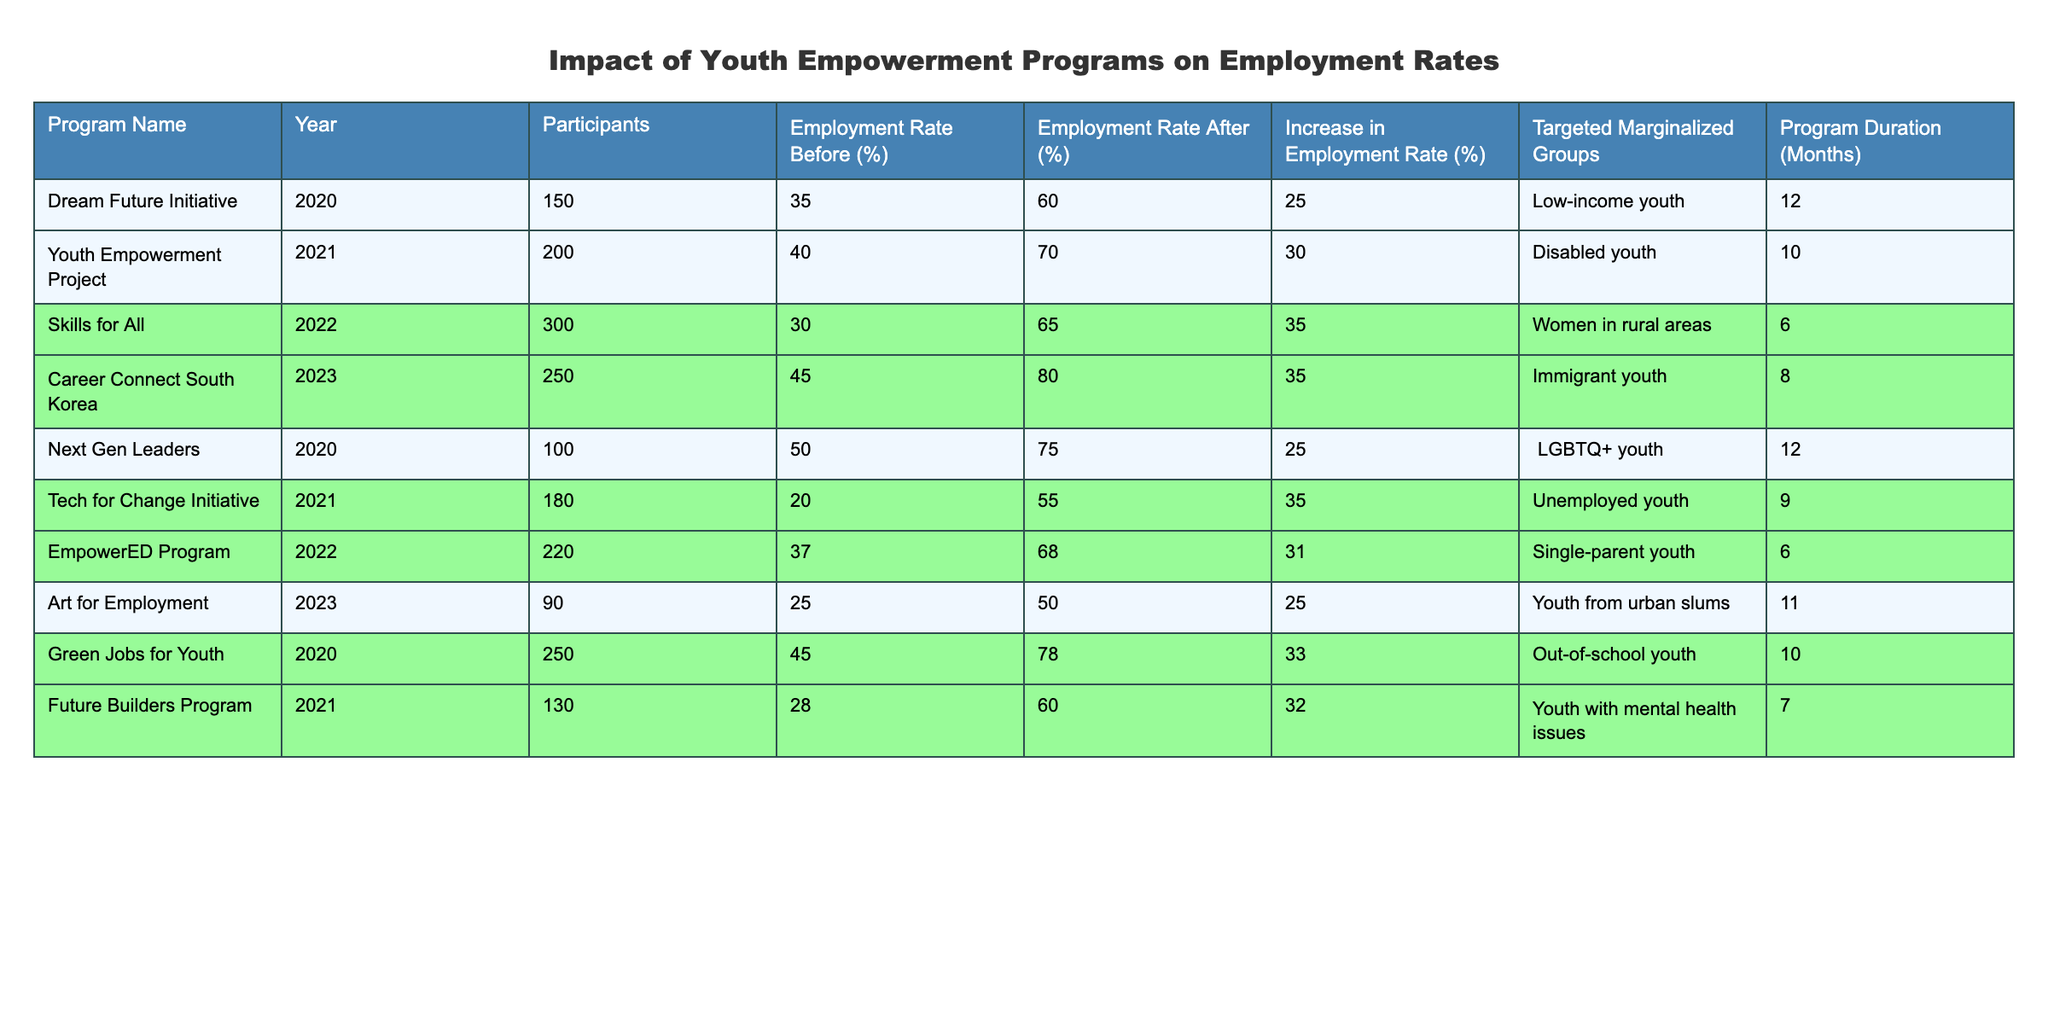What is the program with the highest increase in employment rate? The table shows various programs and their increase in employment rates. The program with the highest increase is "Skills for All," which has an increase of 35%.
Answer: Skills for All What is the employment rate after the "Career Connect South Korea" program? According to the table, the employment rate after the "Career Connect South Korea" program is 80%.
Answer: 80% Which targeted marginalized group had the lowest employment rate before the program? The table lists the employment rates before the programs for different groups. The lowest is "Tech for Change Initiative," with a rate of 20%.
Answer: Unemployed youth What is the average increase in employment rate across all programs? To find the average increase, sum all the increases (25 + 30 + 35 + 35 + 25 + 35 + 31 + 25 + 33 + 32) =  8 + 20 = 308, then divide by the number of programs (10), which gives 30.8%.
Answer: 30.8% Did the "Next Gen Leaders" program benefit LGBTQ+ youth? The table indicates that the "Next Gen Leaders" program had an increase of 25% in employment rate, helping the group effectively. Yes, it benefited LGBTQ+ youth.
Answer: Yes How many programs had an employment rate increase greater than 30%? The table shows that "Youth Empowerment Project," "Skills for All," "Career Connect South Korea," "Tech for Change Initiative," "EmpowerED Program," and "Green Jobs for Youth" all had increases greater than 30%. Counting these gives a total of 6 programs.
Answer: 6 Which program had the shortest duration, and what was its employment rate after? By reviewing the program durations, "Skills for All" has the shortest duration of 6 months, and its employment rate after is 65%.
Answer: Skills for All; 65% Is there any program targeting single-parent youth that achieved more than a 30% increase in employment rates? The "EmpowerED Program," which targets single-parent youth, achieved a 31% increase in employment rates, which is more than 30%.
Answer: Yes 